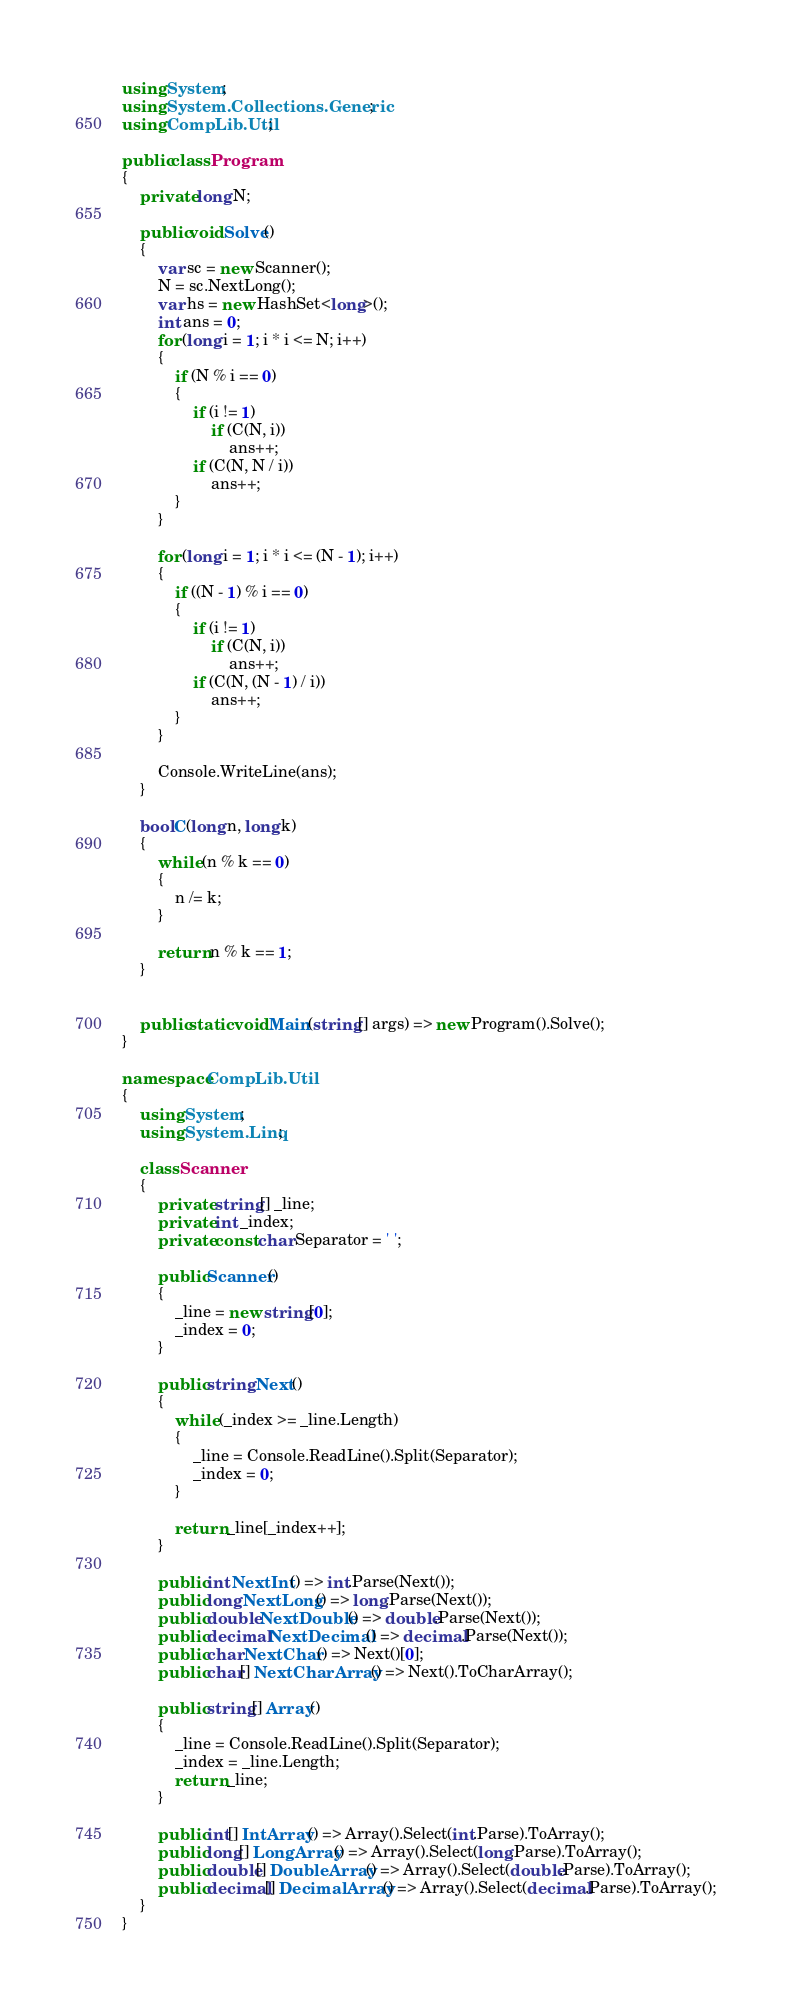<code> <loc_0><loc_0><loc_500><loc_500><_C#_>using System;
using System.Collections.Generic;
using CompLib.Util;

public class Program
{
    private long N;

    public void Solve()
    {
        var sc = new Scanner();
        N = sc.NextLong();
        var hs = new HashSet<long>();
        int ans = 0;
        for (long i = 1; i * i <= N; i++)
        {
            if (N % i == 0)
            {
                if (i != 1)
                    if (C(N, i))
                        ans++;
                if (C(N, N / i))
                    ans++;
            }
        }

        for (long i = 1; i * i <= (N - 1); i++)
        {
            if ((N - 1) % i == 0)
            {
                if (i != 1)
                    if (C(N, i))
                        ans++;
                if (C(N, (N - 1) / i))
                    ans++;
            }
        }

        Console.WriteLine(ans);
    }

    bool C(long n, long k)
    {
        while (n % k == 0)
        {
            n /= k;
        }

        return n % k == 1;
    }


    public static void Main(string[] args) => new Program().Solve();
}

namespace CompLib.Util
{
    using System;
    using System.Linq;

    class Scanner
    {
        private string[] _line;
        private int _index;
        private const char Separator = ' ';

        public Scanner()
        {
            _line = new string[0];
            _index = 0;
        }

        public string Next()
        {
            while (_index >= _line.Length)
            {
                _line = Console.ReadLine().Split(Separator);
                _index = 0;
            }

            return _line[_index++];
        }

        public int NextInt() => int.Parse(Next());
        public long NextLong() => long.Parse(Next());
        public double NextDouble() => double.Parse(Next());
        public decimal NextDecimal() => decimal.Parse(Next());
        public char NextChar() => Next()[0];
        public char[] NextCharArray() => Next().ToCharArray();

        public string[] Array()
        {
            _line = Console.ReadLine().Split(Separator);
            _index = _line.Length;
            return _line;
        }

        public int[] IntArray() => Array().Select(int.Parse).ToArray();
        public long[] LongArray() => Array().Select(long.Parse).ToArray();
        public double[] DoubleArray() => Array().Select(double.Parse).ToArray();
        public decimal[] DecimalArray() => Array().Select(decimal.Parse).ToArray();
    }
}</code> 